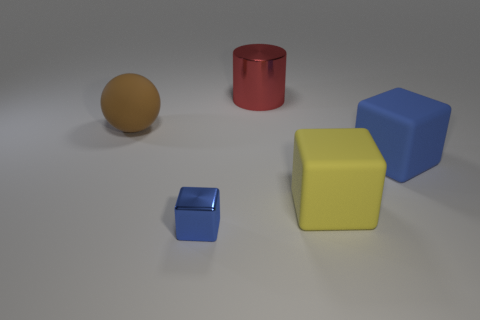Subtract all yellow cubes. How many cubes are left? 2 Subtract all big matte blocks. How many blocks are left? 1 Subtract all balls. How many objects are left? 4 Subtract 1 cylinders. How many cylinders are left? 0 Add 1 large cylinders. How many large cylinders are left? 2 Add 3 brown balls. How many brown balls exist? 4 Add 1 small yellow shiny balls. How many objects exist? 6 Subtract 0 blue cylinders. How many objects are left? 5 Subtract all brown blocks. Subtract all gray spheres. How many blocks are left? 3 Subtract all brown cylinders. How many red blocks are left? 0 